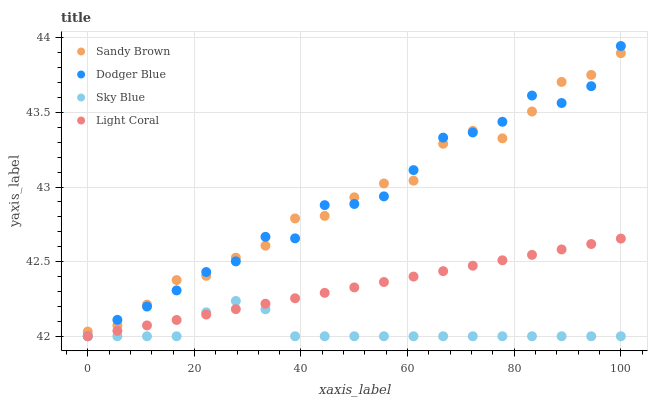Does Sky Blue have the minimum area under the curve?
Answer yes or no. Yes. Does Sandy Brown have the maximum area under the curve?
Answer yes or no. Yes. Does Dodger Blue have the minimum area under the curve?
Answer yes or no. No. Does Dodger Blue have the maximum area under the curve?
Answer yes or no. No. Is Light Coral the smoothest?
Answer yes or no. Yes. Is Sandy Brown the roughest?
Answer yes or no. Yes. Is Dodger Blue the smoothest?
Answer yes or no. No. Is Dodger Blue the roughest?
Answer yes or no. No. Does Light Coral have the lowest value?
Answer yes or no. Yes. Does Dodger Blue have the lowest value?
Answer yes or no. No. Does Dodger Blue have the highest value?
Answer yes or no. Yes. Does Sandy Brown have the highest value?
Answer yes or no. No. Is Light Coral less than Sandy Brown?
Answer yes or no. Yes. Is Sandy Brown greater than Light Coral?
Answer yes or no. Yes. Does Sandy Brown intersect Dodger Blue?
Answer yes or no. Yes. Is Sandy Brown less than Dodger Blue?
Answer yes or no. No. Is Sandy Brown greater than Dodger Blue?
Answer yes or no. No. Does Light Coral intersect Sandy Brown?
Answer yes or no. No. 